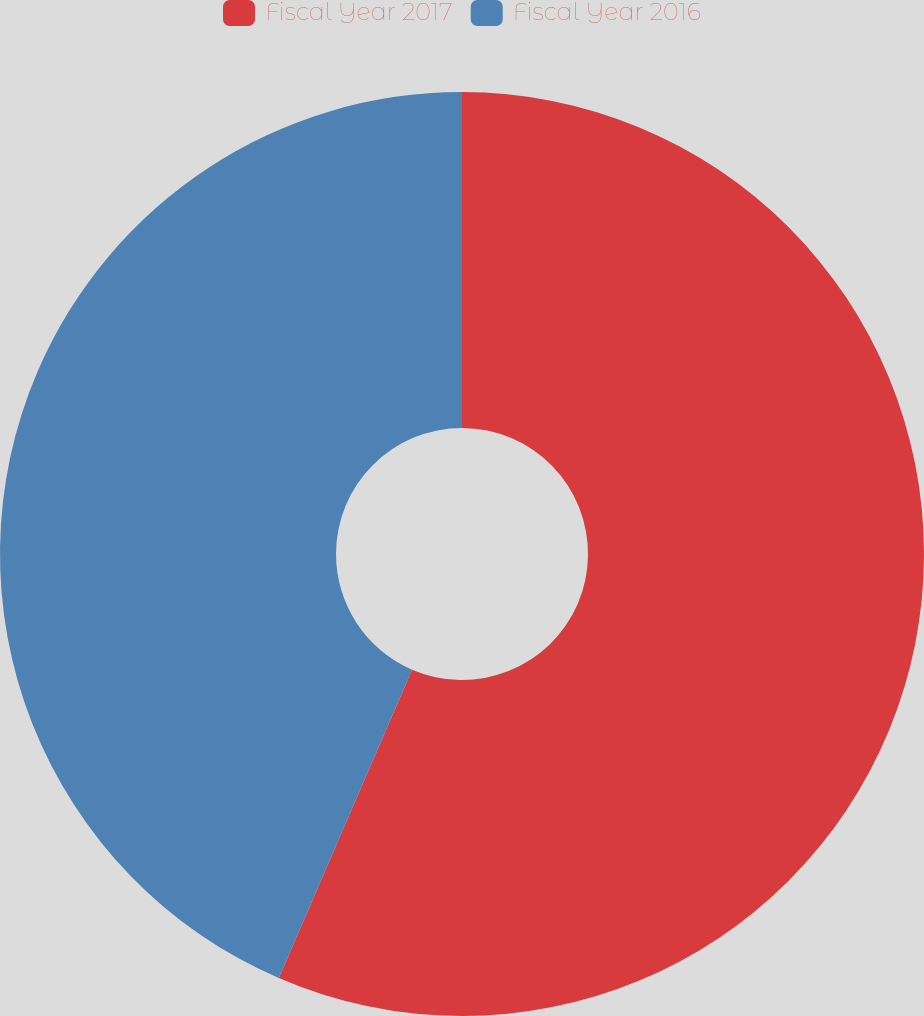Convert chart to OTSL. <chart><loc_0><loc_0><loc_500><loc_500><pie_chart><fcel>Fiscal Year 2017<fcel>Fiscal Year 2016<nl><fcel>56.49%<fcel>43.51%<nl></chart> 